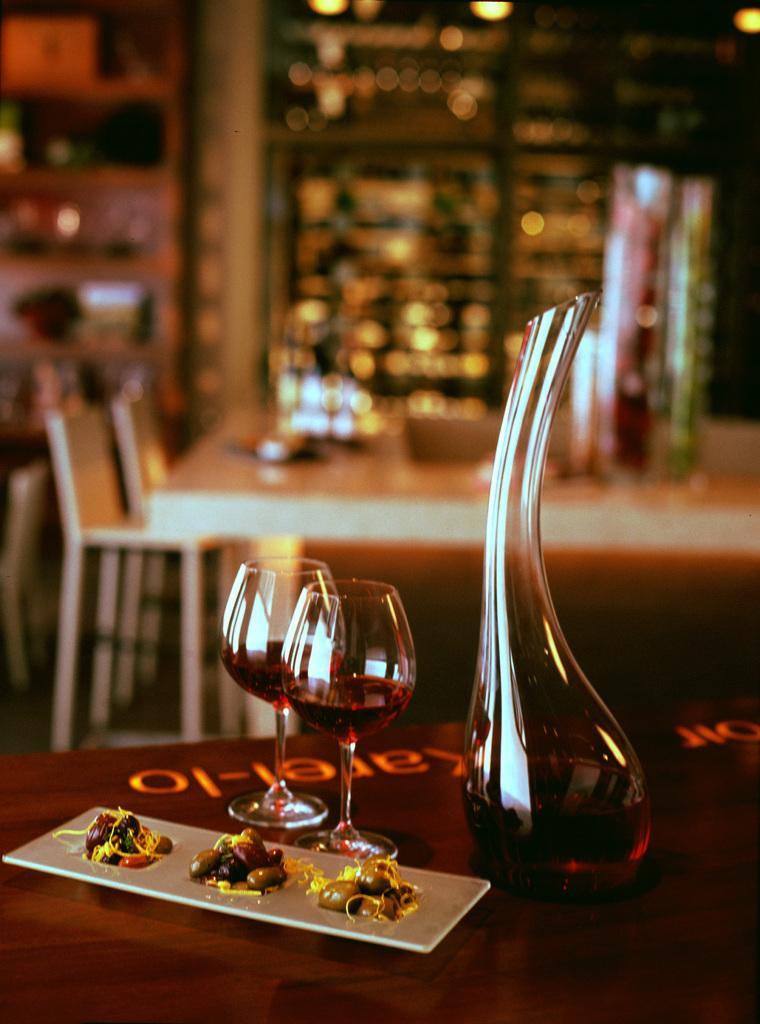Can you describe this image briefly? These are the two wine glasses and a glass jar, a food plate. 